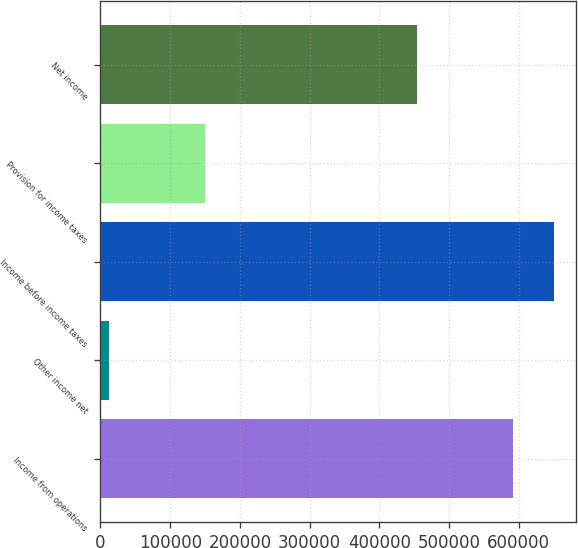Convert chart to OTSL. <chart><loc_0><loc_0><loc_500><loc_500><bar_chart><fcel>Income from operations<fcel>Other income net<fcel>Income before income taxes<fcel>Provision for income taxes<fcel>Net income<nl><fcel>590899<fcel>12861<fcel>649989<fcel>150071<fcel>453689<nl></chart> 